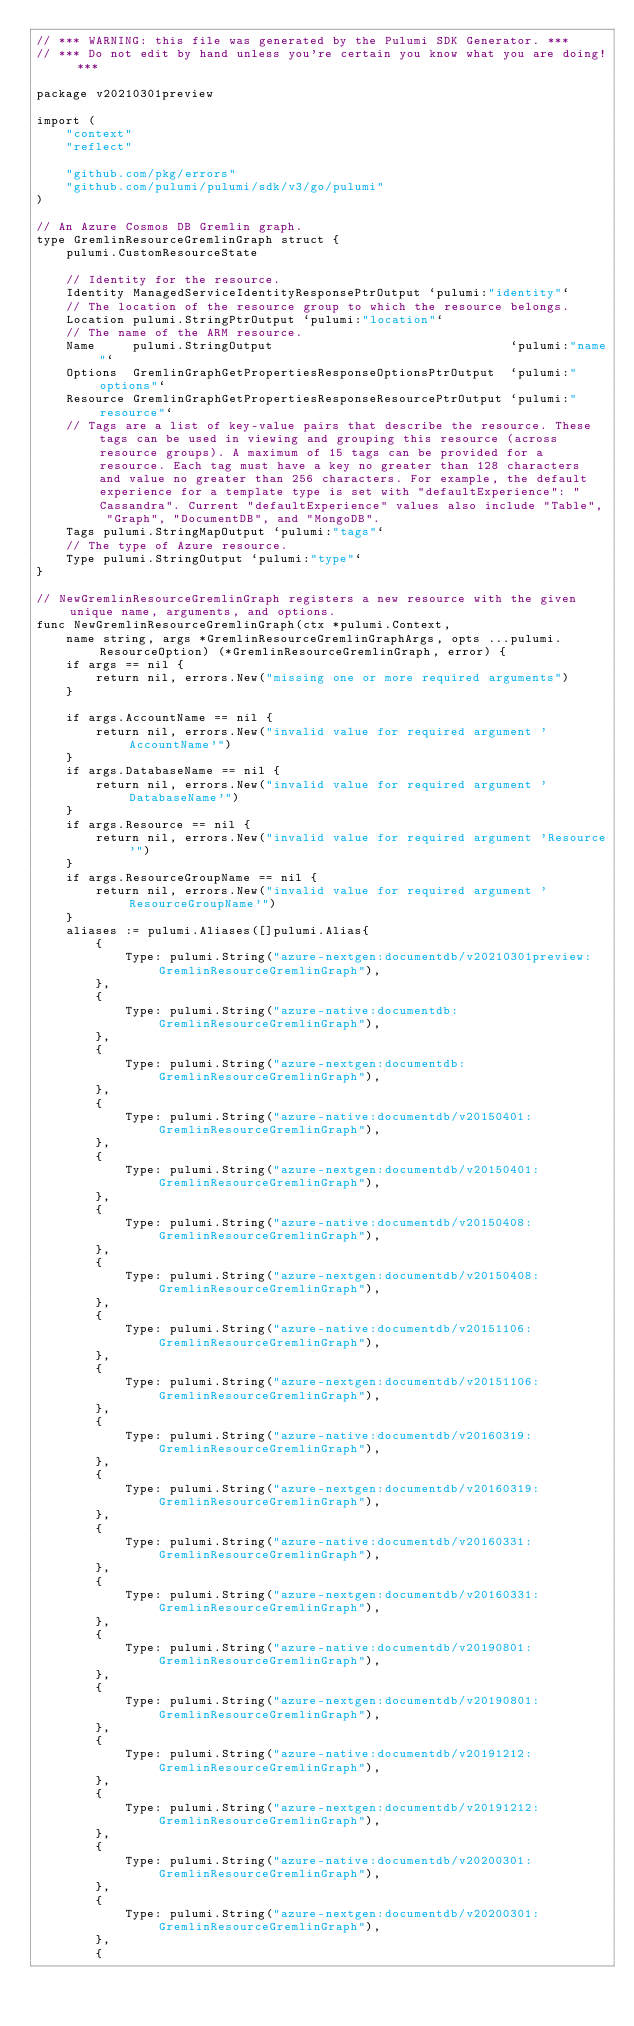<code> <loc_0><loc_0><loc_500><loc_500><_Go_>// *** WARNING: this file was generated by the Pulumi SDK Generator. ***
// *** Do not edit by hand unless you're certain you know what you are doing! ***

package v20210301preview

import (
	"context"
	"reflect"

	"github.com/pkg/errors"
	"github.com/pulumi/pulumi/sdk/v3/go/pulumi"
)

// An Azure Cosmos DB Gremlin graph.
type GremlinResourceGremlinGraph struct {
	pulumi.CustomResourceState

	// Identity for the resource.
	Identity ManagedServiceIdentityResponsePtrOutput `pulumi:"identity"`
	// The location of the resource group to which the resource belongs.
	Location pulumi.StringPtrOutput `pulumi:"location"`
	// The name of the ARM resource.
	Name     pulumi.StringOutput                                `pulumi:"name"`
	Options  GremlinGraphGetPropertiesResponseOptionsPtrOutput  `pulumi:"options"`
	Resource GremlinGraphGetPropertiesResponseResourcePtrOutput `pulumi:"resource"`
	// Tags are a list of key-value pairs that describe the resource. These tags can be used in viewing and grouping this resource (across resource groups). A maximum of 15 tags can be provided for a resource. Each tag must have a key no greater than 128 characters and value no greater than 256 characters. For example, the default experience for a template type is set with "defaultExperience": "Cassandra". Current "defaultExperience" values also include "Table", "Graph", "DocumentDB", and "MongoDB".
	Tags pulumi.StringMapOutput `pulumi:"tags"`
	// The type of Azure resource.
	Type pulumi.StringOutput `pulumi:"type"`
}

// NewGremlinResourceGremlinGraph registers a new resource with the given unique name, arguments, and options.
func NewGremlinResourceGremlinGraph(ctx *pulumi.Context,
	name string, args *GremlinResourceGremlinGraphArgs, opts ...pulumi.ResourceOption) (*GremlinResourceGremlinGraph, error) {
	if args == nil {
		return nil, errors.New("missing one or more required arguments")
	}

	if args.AccountName == nil {
		return nil, errors.New("invalid value for required argument 'AccountName'")
	}
	if args.DatabaseName == nil {
		return nil, errors.New("invalid value for required argument 'DatabaseName'")
	}
	if args.Resource == nil {
		return nil, errors.New("invalid value for required argument 'Resource'")
	}
	if args.ResourceGroupName == nil {
		return nil, errors.New("invalid value for required argument 'ResourceGroupName'")
	}
	aliases := pulumi.Aliases([]pulumi.Alias{
		{
			Type: pulumi.String("azure-nextgen:documentdb/v20210301preview:GremlinResourceGremlinGraph"),
		},
		{
			Type: pulumi.String("azure-native:documentdb:GremlinResourceGremlinGraph"),
		},
		{
			Type: pulumi.String("azure-nextgen:documentdb:GremlinResourceGremlinGraph"),
		},
		{
			Type: pulumi.String("azure-native:documentdb/v20150401:GremlinResourceGremlinGraph"),
		},
		{
			Type: pulumi.String("azure-nextgen:documentdb/v20150401:GremlinResourceGremlinGraph"),
		},
		{
			Type: pulumi.String("azure-native:documentdb/v20150408:GremlinResourceGremlinGraph"),
		},
		{
			Type: pulumi.String("azure-nextgen:documentdb/v20150408:GremlinResourceGremlinGraph"),
		},
		{
			Type: pulumi.String("azure-native:documentdb/v20151106:GremlinResourceGremlinGraph"),
		},
		{
			Type: pulumi.String("azure-nextgen:documentdb/v20151106:GremlinResourceGremlinGraph"),
		},
		{
			Type: pulumi.String("azure-native:documentdb/v20160319:GremlinResourceGremlinGraph"),
		},
		{
			Type: pulumi.String("azure-nextgen:documentdb/v20160319:GremlinResourceGremlinGraph"),
		},
		{
			Type: pulumi.String("azure-native:documentdb/v20160331:GremlinResourceGremlinGraph"),
		},
		{
			Type: pulumi.String("azure-nextgen:documentdb/v20160331:GremlinResourceGremlinGraph"),
		},
		{
			Type: pulumi.String("azure-native:documentdb/v20190801:GremlinResourceGremlinGraph"),
		},
		{
			Type: pulumi.String("azure-nextgen:documentdb/v20190801:GremlinResourceGremlinGraph"),
		},
		{
			Type: pulumi.String("azure-native:documentdb/v20191212:GremlinResourceGremlinGraph"),
		},
		{
			Type: pulumi.String("azure-nextgen:documentdb/v20191212:GremlinResourceGremlinGraph"),
		},
		{
			Type: pulumi.String("azure-native:documentdb/v20200301:GremlinResourceGremlinGraph"),
		},
		{
			Type: pulumi.String("azure-nextgen:documentdb/v20200301:GremlinResourceGremlinGraph"),
		},
		{</code> 